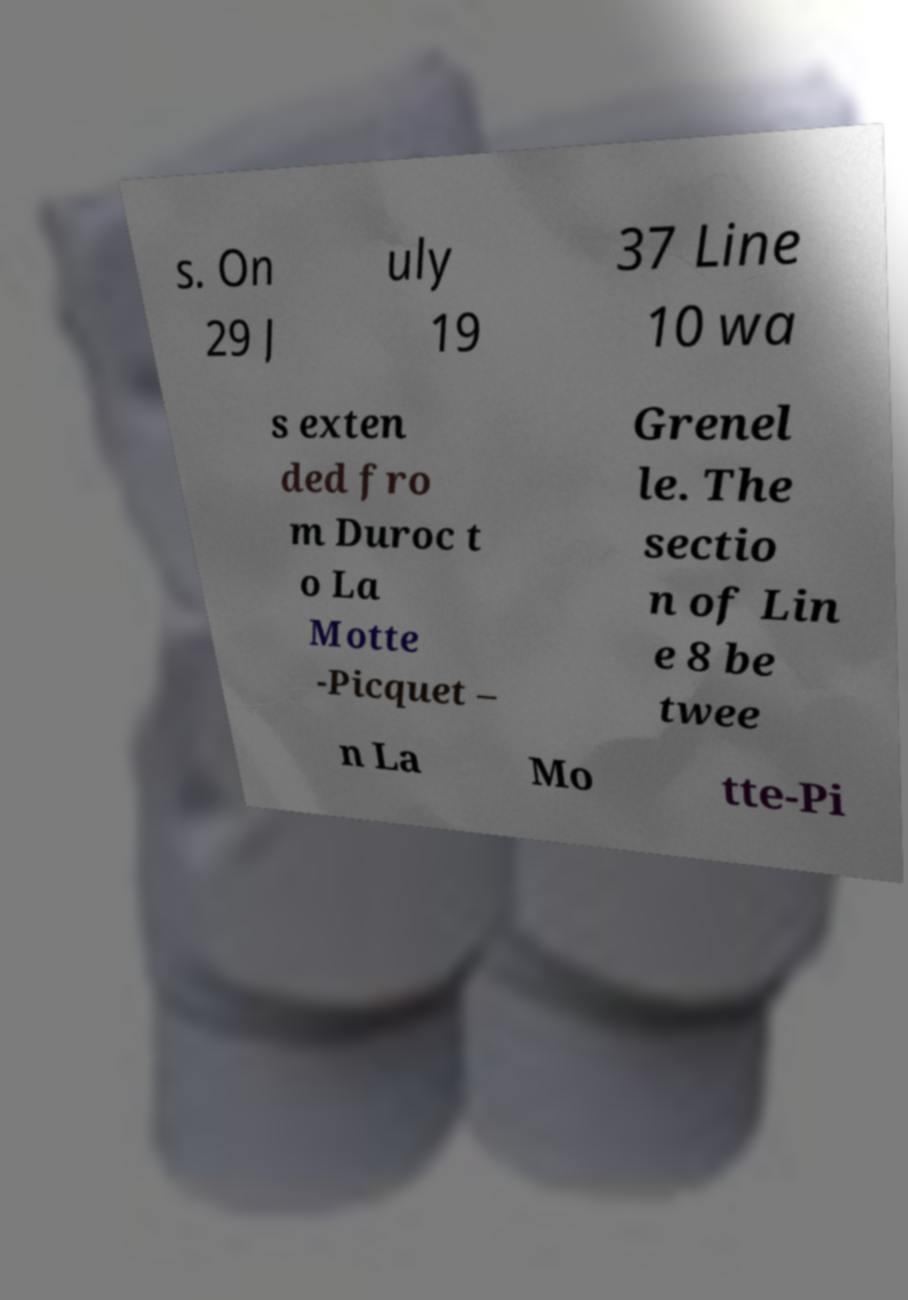For documentation purposes, I need the text within this image transcribed. Could you provide that? s. On 29 J uly 19 37 Line 10 wa s exten ded fro m Duroc t o La Motte -Picquet – Grenel le. The sectio n of Lin e 8 be twee n La Mo tte-Pi 